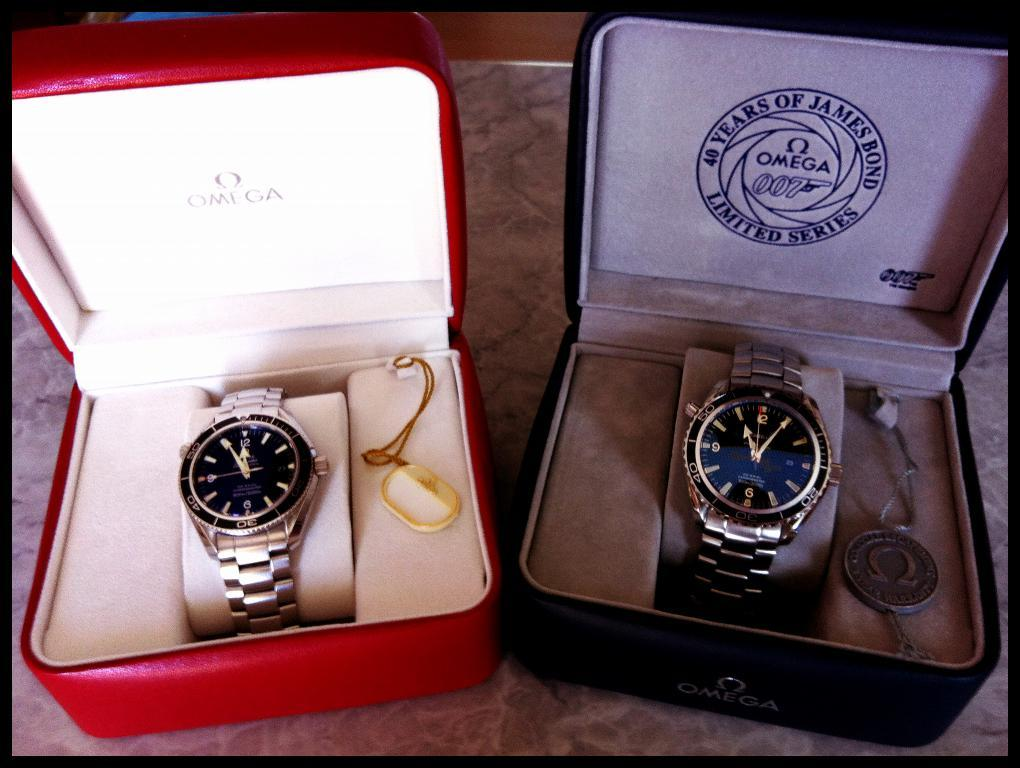Provide a one-sentence caption for the provided image. Two Omega watches, one is a limited edition of a 007 James Bond watch. 